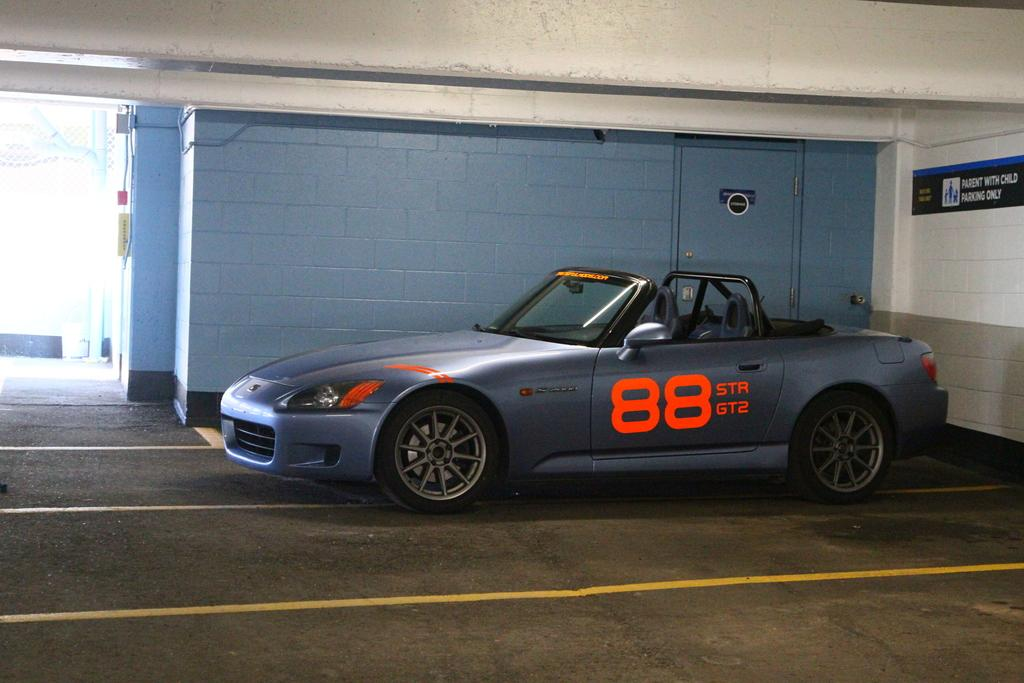What is the main subject in the center of the image? There is a car in the center of the image. What is located beside the car? There is a door beside the car. What can be found in the center of the image besides the car? The center of the image features a well. What type of structure is on the left side of the image? There is a building on the left side of the image. Can you see a kite flying in the sky in the image? There is no kite visible in the image. Is there a picture of a balloon hanging on the building in the image? There is no picture of a balloon or any balloon present in the image. 